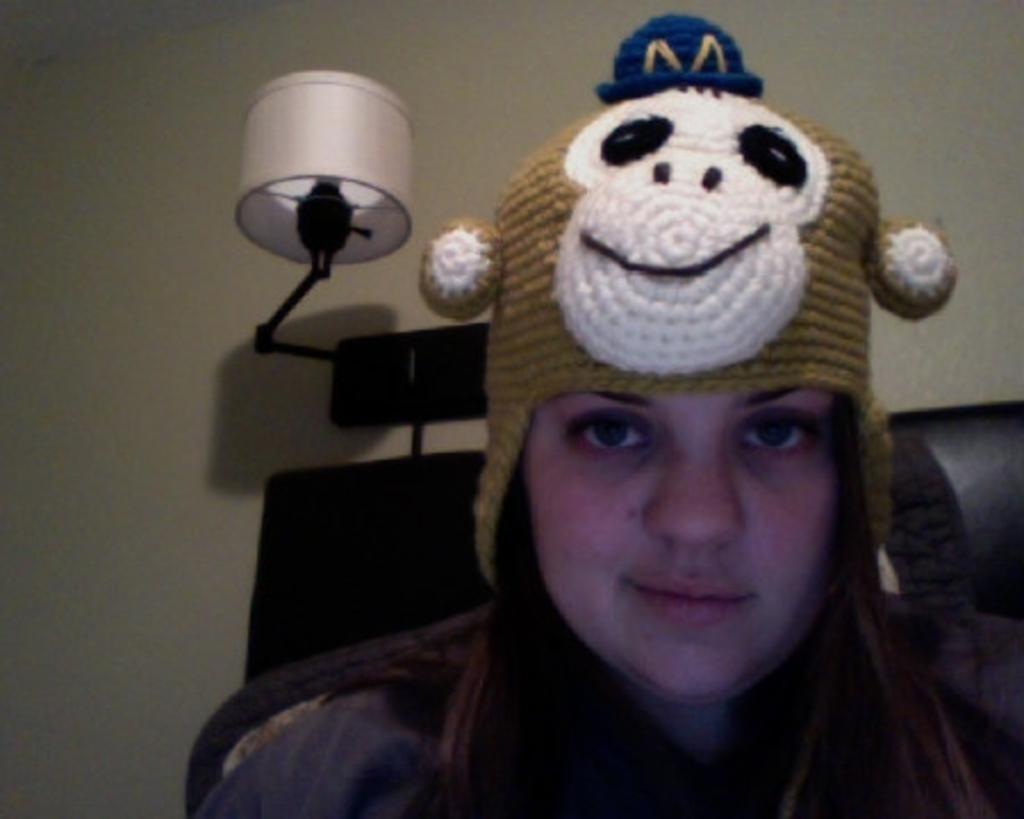Please provide a concise description of this image. A woman is looking at this side, she wore monkey cap. In the middle there is a lamp on the wall. 